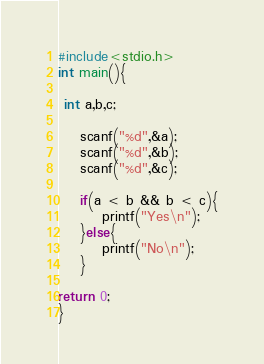<code> <loc_0><loc_0><loc_500><loc_500><_C_>#include<stdio.h>
int main(){

 int a,b,c;

	scanf("%d",&a);
	scanf("%d",&b);
	scanf("%d",&c);

	if(a < b && b < c){
		printf("Yes\n");
	}else{
		printf("No\n");
	}
	
return 0;
}</code> 